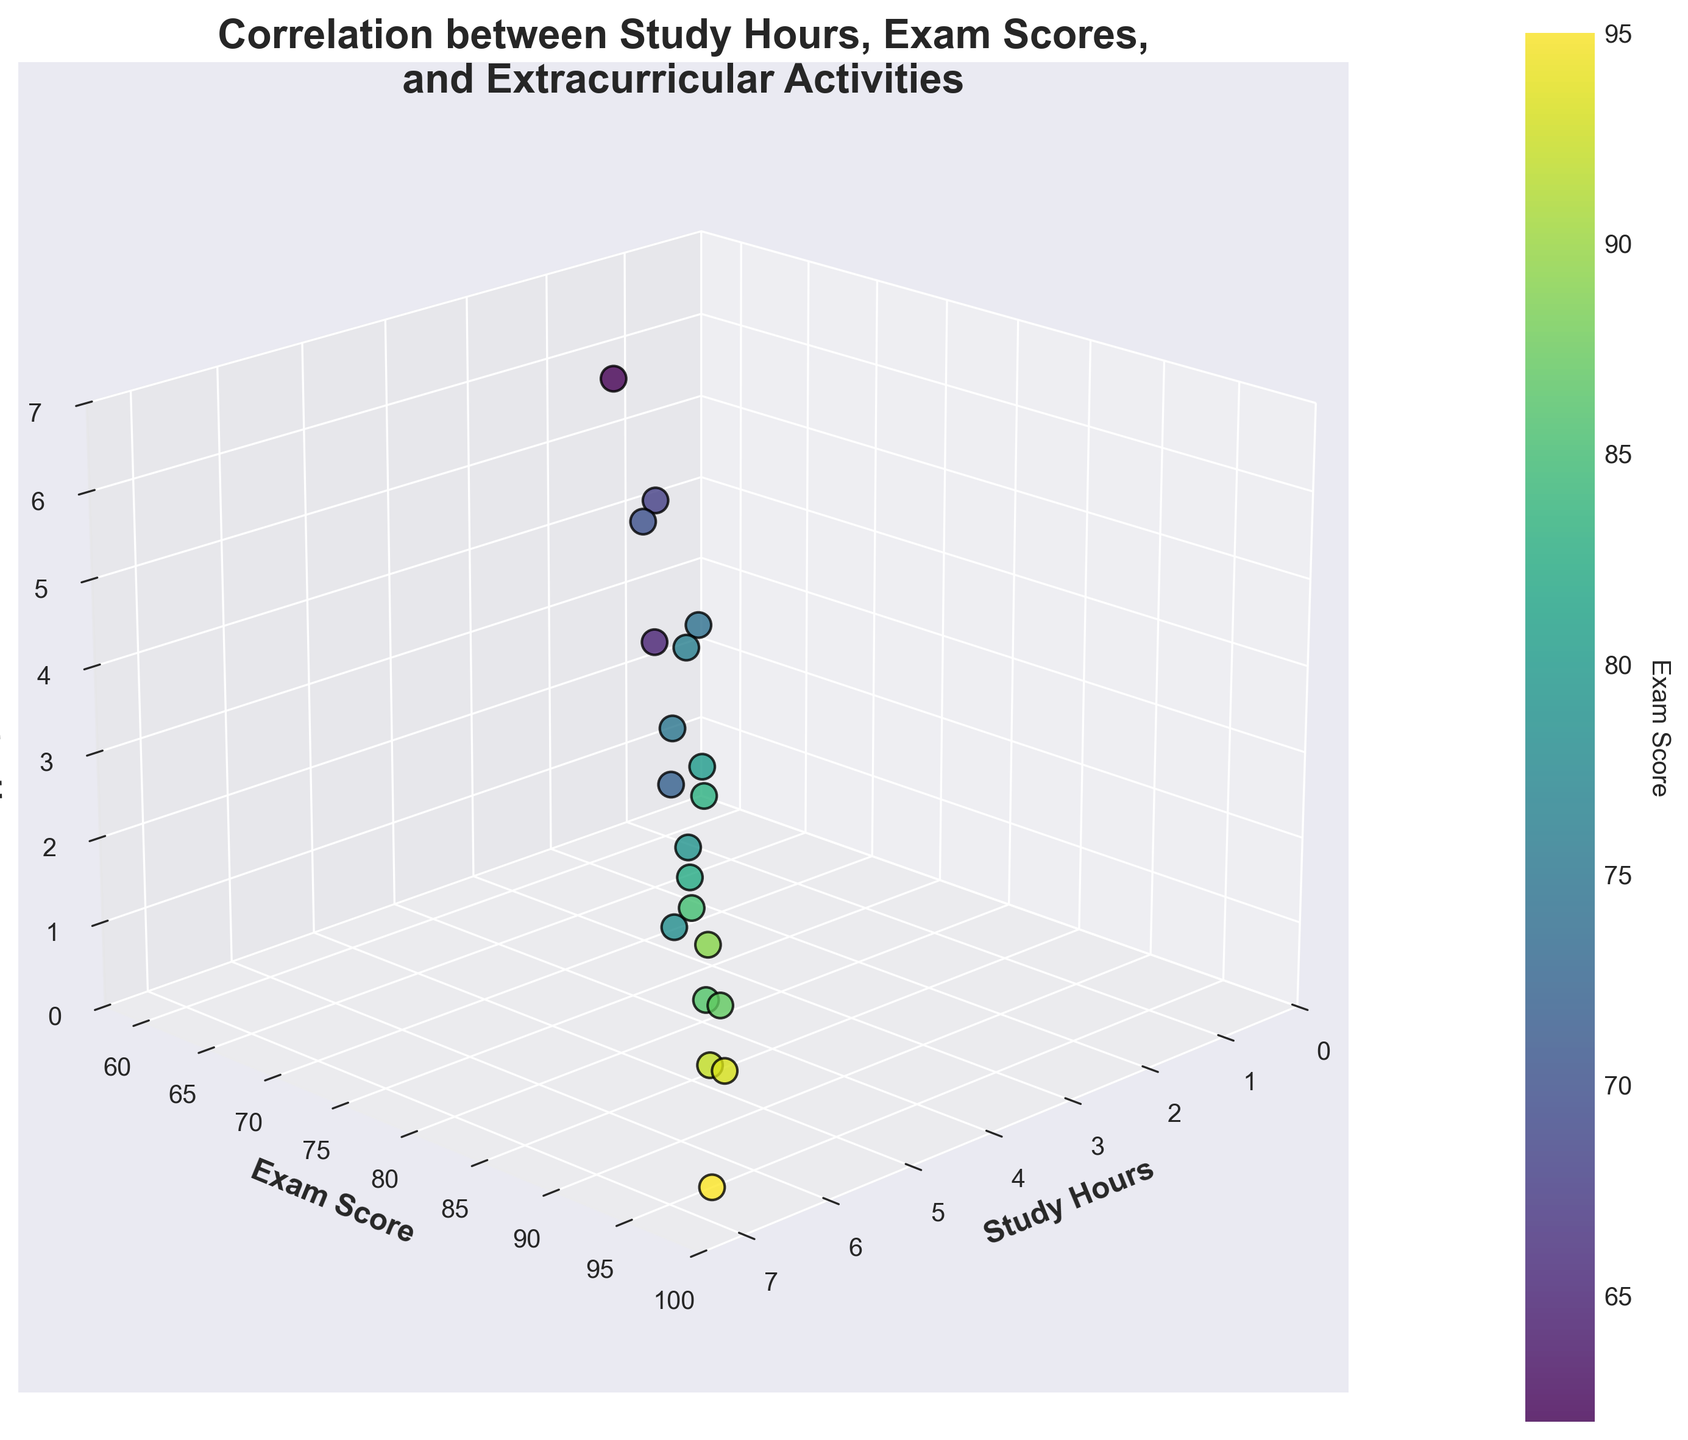How many data points are shown in the figure? The data visualization includes all the data points provided in the dataset. Count the number of rows in the dataset to get the total number of data points. There are 20 rows, so there are 20 data points.
Answer: 20 What is the highest exam score? To find the highest exam score, observe the exam scores on the y-axis and identify the maximum value. The highest exam score in the dataset is 95.
Answer: 95 Which student has the maximum number of extracurricular hours? Examine the z-axis (Extracurricular Hours) and locate the maximum value on that axis. The highest value is 6, associated with 2 study hours and an exam score of 62.
Answer: The student with 62 exam score and 2 study hours Is there a trend between study hours and exam scores? Observing the scatter plot, we can see that as the number of study hours (x-axis) increases, the exam scores (y-axis) also tend to increase, indicating a positive correlation.
Answer: Yes, there is a positive trend What is the average exam score of students who study more than 5 hours? Identify the data points where the study hours exceed 5, and then calculate the average exam score for those points. For study hours of 6, 6.5, and 6, the exam scores are 92, 95, and 93, respectively. Average = (92+95+93)/3 = 280/3 = 93.33.
Answer: 93.33 Do students with fewer extracurricular hours tend to have higher exam scores? Locate students with lower extracurricular hours on the z-axis, then check if the exam scores on the y-axis are generally higher. Lower extracurricular hours (0, 1, 2) often correspond to higher exam scores.
Answer: Yes How does exam score vary for students with exactly 4 hours of study? Identify all points where study hours (x-axis) equal 4, then list the respective exam scores. The corresponding exam scores are 78, 80, and 79.
Answer: 78, 80, 79 Which student has the lowest exam score with less than 3 hours of study? Filter the data to find students with study hours less than 3, then locate the lowest exam score among them. For study hours 2, 2.5, 2, the exam scores are 65, 68, 62. The lowest is 62.
Answer: The student with 2 study hours and 6 extracurricular hours How does the number of extracurricular hours affect exam scores for students with study hours between 3 and 5? Filter points where study hours (x-axis) are between 3 and 5, and analyze the exam scores (y-axis) concerning the extracurricular hours (z-axis). A mix of moderate exam scores and varied extracurricular hours is observed.
Answer: Varies; no clear trend Is there any data point that has a low study hour count but a high exam score? Look for data points with low study hours on the x-axis but high exam scores on the y-axis. For example, 3 study hours with an exam score of 74 or more.
Answer: Yes, 3 study hours and 74 exam score 